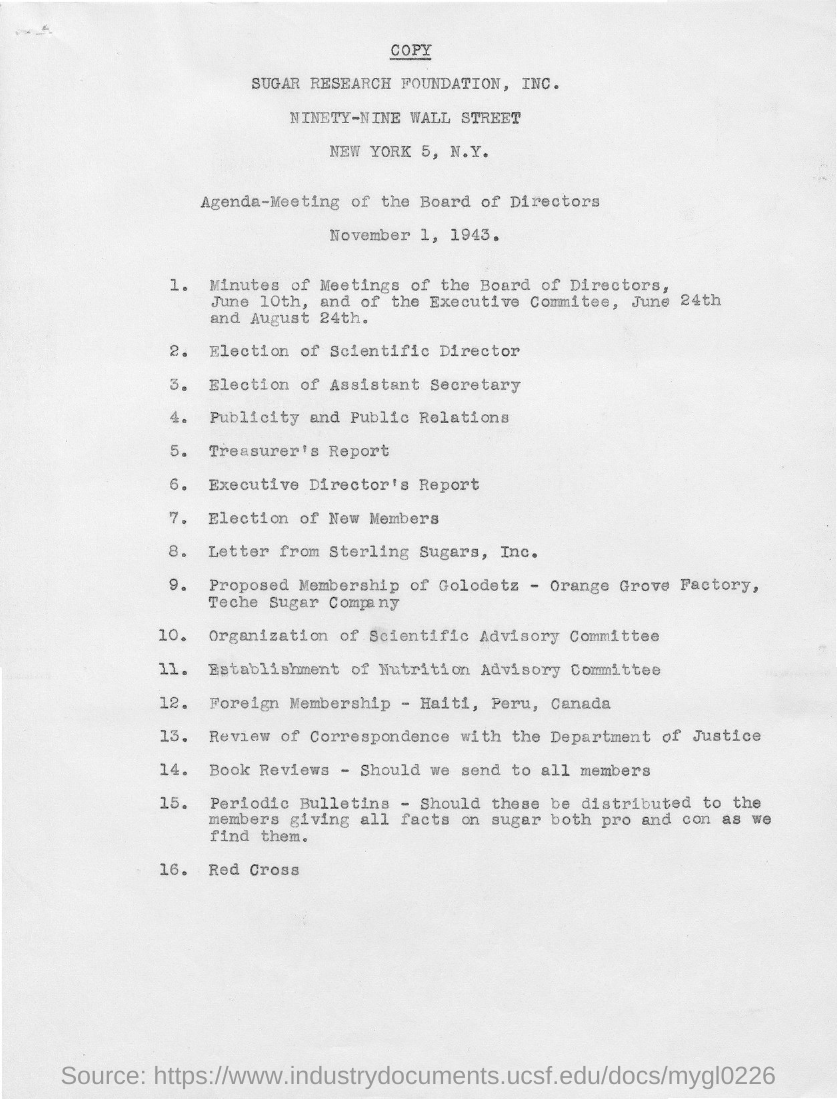It is the agenda for what?
 meeting of the board of directors 